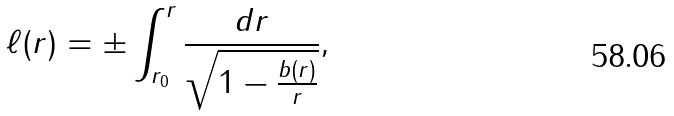<formula> <loc_0><loc_0><loc_500><loc_500>\ell ( r ) = \pm \int ^ { r } _ { r _ { 0 } } { \frac { d r } { \sqrt { 1 - \frac { b ( r ) } { r } } } } ,</formula> 